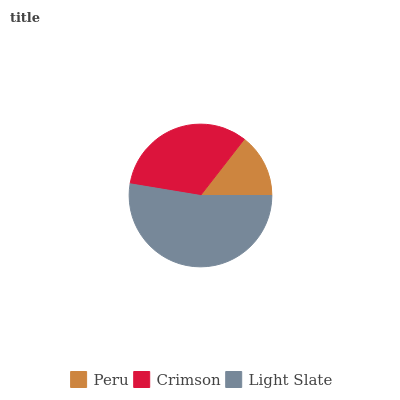Is Peru the minimum?
Answer yes or no. Yes. Is Light Slate the maximum?
Answer yes or no. Yes. Is Crimson the minimum?
Answer yes or no. No. Is Crimson the maximum?
Answer yes or no. No. Is Crimson greater than Peru?
Answer yes or no. Yes. Is Peru less than Crimson?
Answer yes or no. Yes. Is Peru greater than Crimson?
Answer yes or no. No. Is Crimson less than Peru?
Answer yes or no. No. Is Crimson the high median?
Answer yes or no. Yes. Is Crimson the low median?
Answer yes or no. Yes. Is Light Slate the high median?
Answer yes or no. No. Is Light Slate the low median?
Answer yes or no. No. 